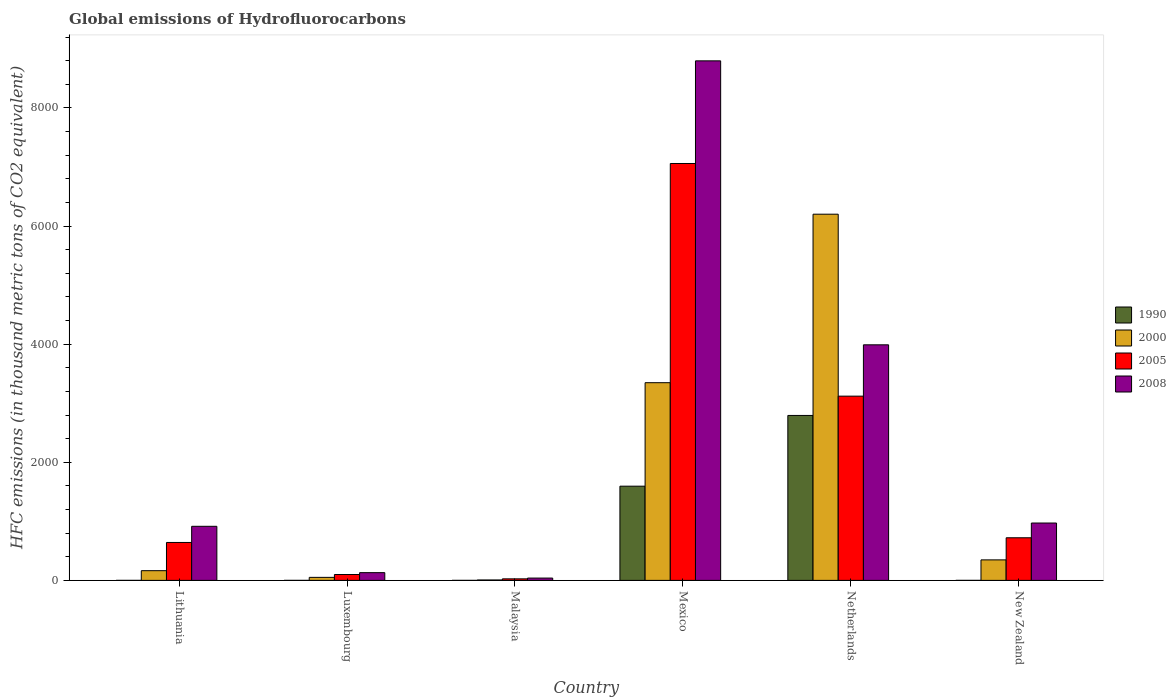How many groups of bars are there?
Provide a short and direct response. 6. How many bars are there on the 3rd tick from the left?
Your answer should be very brief. 4. In how many cases, is the number of bars for a given country not equal to the number of legend labels?
Your answer should be very brief. 0. What is the global emissions of Hydrofluorocarbons in 1990 in Malaysia?
Provide a succinct answer. 0.1. Across all countries, what is the maximum global emissions of Hydrofluorocarbons in 1990?
Provide a short and direct response. 2792.9. Across all countries, what is the minimum global emissions of Hydrofluorocarbons in 2005?
Your response must be concise. 26.1. In which country was the global emissions of Hydrofluorocarbons in 2005 maximum?
Keep it short and to the point. Mexico. In which country was the global emissions of Hydrofluorocarbons in 2000 minimum?
Your answer should be compact. Malaysia. What is the total global emissions of Hydrofluorocarbons in 1990 in the graph?
Ensure brevity in your answer.  4388.7. What is the difference between the global emissions of Hydrofluorocarbons in 2005 in Luxembourg and that in Netherlands?
Offer a terse response. -3020. What is the difference between the global emissions of Hydrofluorocarbons in 2008 in New Zealand and the global emissions of Hydrofluorocarbons in 2005 in Lithuania?
Give a very brief answer. 329.3. What is the average global emissions of Hydrofluorocarbons in 2008 per country?
Make the answer very short. 2473.87. What is the difference between the global emissions of Hydrofluorocarbons of/in 1990 and global emissions of Hydrofluorocarbons of/in 2008 in Mexico?
Your response must be concise. -7201.6. In how many countries, is the global emissions of Hydrofluorocarbons in 2005 greater than 8400 thousand metric tons?
Give a very brief answer. 0. What is the ratio of the global emissions of Hydrofluorocarbons in 1990 in Lithuania to that in Mexico?
Offer a very short reply. 6.268413464552123e-5. What is the difference between the highest and the second highest global emissions of Hydrofluorocarbons in 1990?
Make the answer very short. 1197.6. What is the difference between the highest and the lowest global emissions of Hydrofluorocarbons in 2000?
Your answer should be very brief. 6193.5. In how many countries, is the global emissions of Hydrofluorocarbons in 2005 greater than the average global emissions of Hydrofluorocarbons in 2005 taken over all countries?
Offer a terse response. 2. Is it the case that in every country, the sum of the global emissions of Hydrofluorocarbons in 2008 and global emissions of Hydrofluorocarbons in 2005 is greater than the sum of global emissions of Hydrofluorocarbons in 2000 and global emissions of Hydrofluorocarbons in 1990?
Offer a terse response. No. What does the 3rd bar from the right in Malaysia represents?
Provide a succinct answer. 2000. Is it the case that in every country, the sum of the global emissions of Hydrofluorocarbons in 2005 and global emissions of Hydrofluorocarbons in 1990 is greater than the global emissions of Hydrofluorocarbons in 2008?
Provide a succinct answer. No. Are all the bars in the graph horizontal?
Provide a succinct answer. No. How many countries are there in the graph?
Offer a terse response. 6. What is the difference between two consecutive major ticks on the Y-axis?
Ensure brevity in your answer.  2000. Are the values on the major ticks of Y-axis written in scientific E-notation?
Your response must be concise. No. Where does the legend appear in the graph?
Offer a very short reply. Center right. How are the legend labels stacked?
Your answer should be very brief. Vertical. What is the title of the graph?
Give a very brief answer. Global emissions of Hydrofluorocarbons. What is the label or title of the Y-axis?
Your answer should be very brief. HFC emissions (in thousand metric tons of CO2 equivalent). What is the HFC emissions (in thousand metric tons of CO2 equivalent) of 2000 in Lithuania?
Offer a terse response. 164.5. What is the HFC emissions (in thousand metric tons of CO2 equivalent) of 2005 in Lithuania?
Your answer should be very brief. 642.1. What is the HFC emissions (in thousand metric tons of CO2 equivalent) in 2008 in Lithuania?
Your answer should be compact. 915.7. What is the HFC emissions (in thousand metric tons of CO2 equivalent) of 1990 in Luxembourg?
Your response must be concise. 0.1. What is the HFC emissions (in thousand metric tons of CO2 equivalent) in 2000 in Luxembourg?
Your answer should be compact. 51.1. What is the HFC emissions (in thousand metric tons of CO2 equivalent) in 2005 in Luxembourg?
Make the answer very short. 99.5. What is the HFC emissions (in thousand metric tons of CO2 equivalent) of 2008 in Luxembourg?
Keep it short and to the point. 131.2. What is the HFC emissions (in thousand metric tons of CO2 equivalent) of 2005 in Malaysia?
Your answer should be compact. 26.1. What is the HFC emissions (in thousand metric tons of CO2 equivalent) of 2008 in Malaysia?
Offer a terse response. 39.2. What is the HFC emissions (in thousand metric tons of CO2 equivalent) in 1990 in Mexico?
Your answer should be very brief. 1595.3. What is the HFC emissions (in thousand metric tons of CO2 equivalent) in 2000 in Mexico?
Ensure brevity in your answer.  3347.3. What is the HFC emissions (in thousand metric tons of CO2 equivalent) of 2005 in Mexico?
Offer a terse response. 7058.9. What is the HFC emissions (in thousand metric tons of CO2 equivalent) of 2008 in Mexico?
Provide a succinct answer. 8796.9. What is the HFC emissions (in thousand metric tons of CO2 equivalent) of 1990 in Netherlands?
Give a very brief answer. 2792.9. What is the HFC emissions (in thousand metric tons of CO2 equivalent) of 2000 in Netherlands?
Offer a terse response. 6200.4. What is the HFC emissions (in thousand metric tons of CO2 equivalent) of 2005 in Netherlands?
Provide a succinct answer. 3119.5. What is the HFC emissions (in thousand metric tons of CO2 equivalent) in 2008 in Netherlands?
Make the answer very short. 3988.8. What is the HFC emissions (in thousand metric tons of CO2 equivalent) of 2000 in New Zealand?
Provide a succinct answer. 347.3. What is the HFC emissions (in thousand metric tons of CO2 equivalent) of 2005 in New Zealand?
Offer a very short reply. 721.7. What is the HFC emissions (in thousand metric tons of CO2 equivalent) in 2008 in New Zealand?
Your answer should be compact. 971.4. Across all countries, what is the maximum HFC emissions (in thousand metric tons of CO2 equivalent) in 1990?
Ensure brevity in your answer.  2792.9. Across all countries, what is the maximum HFC emissions (in thousand metric tons of CO2 equivalent) of 2000?
Your answer should be compact. 6200.4. Across all countries, what is the maximum HFC emissions (in thousand metric tons of CO2 equivalent) in 2005?
Your answer should be compact. 7058.9. Across all countries, what is the maximum HFC emissions (in thousand metric tons of CO2 equivalent) of 2008?
Make the answer very short. 8796.9. Across all countries, what is the minimum HFC emissions (in thousand metric tons of CO2 equivalent) of 1990?
Ensure brevity in your answer.  0.1. Across all countries, what is the minimum HFC emissions (in thousand metric tons of CO2 equivalent) of 2005?
Keep it short and to the point. 26.1. Across all countries, what is the minimum HFC emissions (in thousand metric tons of CO2 equivalent) of 2008?
Your response must be concise. 39.2. What is the total HFC emissions (in thousand metric tons of CO2 equivalent) in 1990 in the graph?
Your answer should be very brief. 4388.7. What is the total HFC emissions (in thousand metric tons of CO2 equivalent) of 2000 in the graph?
Make the answer very short. 1.01e+04. What is the total HFC emissions (in thousand metric tons of CO2 equivalent) of 2005 in the graph?
Your answer should be very brief. 1.17e+04. What is the total HFC emissions (in thousand metric tons of CO2 equivalent) of 2008 in the graph?
Your answer should be very brief. 1.48e+04. What is the difference between the HFC emissions (in thousand metric tons of CO2 equivalent) in 2000 in Lithuania and that in Luxembourg?
Provide a succinct answer. 113.4. What is the difference between the HFC emissions (in thousand metric tons of CO2 equivalent) in 2005 in Lithuania and that in Luxembourg?
Your answer should be very brief. 542.6. What is the difference between the HFC emissions (in thousand metric tons of CO2 equivalent) of 2008 in Lithuania and that in Luxembourg?
Keep it short and to the point. 784.5. What is the difference between the HFC emissions (in thousand metric tons of CO2 equivalent) of 2000 in Lithuania and that in Malaysia?
Your answer should be very brief. 157.6. What is the difference between the HFC emissions (in thousand metric tons of CO2 equivalent) of 2005 in Lithuania and that in Malaysia?
Offer a terse response. 616. What is the difference between the HFC emissions (in thousand metric tons of CO2 equivalent) in 2008 in Lithuania and that in Malaysia?
Ensure brevity in your answer.  876.5. What is the difference between the HFC emissions (in thousand metric tons of CO2 equivalent) of 1990 in Lithuania and that in Mexico?
Ensure brevity in your answer.  -1595.2. What is the difference between the HFC emissions (in thousand metric tons of CO2 equivalent) of 2000 in Lithuania and that in Mexico?
Your answer should be very brief. -3182.8. What is the difference between the HFC emissions (in thousand metric tons of CO2 equivalent) of 2005 in Lithuania and that in Mexico?
Provide a short and direct response. -6416.8. What is the difference between the HFC emissions (in thousand metric tons of CO2 equivalent) in 2008 in Lithuania and that in Mexico?
Your answer should be compact. -7881.2. What is the difference between the HFC emissions (in thousand metric tons of CO2 equivalent) of 1990 in Lithuania and that in Netherlands?
Give a very brief answer. -2792.8. What is the difference between the HFC emissions (in thousand metric tons of CO2 equivalent) in 2000 in Lithuania and that in Netherlands?
Your answer should be very brief. -6035.9. What is the difference between the HFC emissions (in thousand metric tons of CO2 equivalent) of 2005 in Lithuania and that in Netherlands?
Provide a short and direct response. -2477.4. What is the difference between the HFC emissions (in thousand metric tons of CO2 equivalent) of 2008 in Lithuania and that in Netherlands?
Your answer should be compact. -3073.1. What is the difference between the HFC emissions (in thousand metric tons of CO2 equivalent) in 2000 in Lithuania and that in New Zealand?
Offer a very short reply. -182.8. What is the difference between the HFC emissions (in thousand metric tons of CO2 equivalent) in 2005 in Lithuania and that in New Zealand?
Keep it short and to the point. -79.6. What is the difference between the HFC emissions (in thousand metric tons of CO2 equivalent) in 2008 in Lithuania and that in New Zealand?
Your answer should be very brief. -55.7. What is the difference between the HFC emissions (in thousand metric tons of CO2 equivalent) of 1990 in Luxembourg and that in Malaysia?
Make the answer very short. 0. What is the difference between the HFC emissions (in thousand metric tons of CO2 equivalent) of 2000 in Luxembourg and that in Malaysia?
Offer a terse response. 44.2. What is the difference between the HFC emissions (in thousand metric tons of CO2 equivalent) in 2005 in Luxembourg and that in Malaysia?
Offer a terse response. 73.4. What is the difference between the HFC emissions (in thousand metric tons of CO2 equivalent) in 2008 in Luxembourg and that in Malaysia?
Make the answer very short. 92. What is the difference between the HFC emissions (in thousand metric tons of CO2 equivalent) in 1990 in Luxembourg and that in Mexico?
Your response must be concise. -1595.2. What is the difference between the HFC emissions (in thousand metric tons of CO2 equivalent) of 2000 in Luxembourg and that in Mexico?
Keep it short and to the point. -3296.2. What is the difference between the HFC emissions (in thousand metric tons of CO2 equivalent) of 2005 in Luxembourg and that in Mexico?
Provide a succinct answer. -6959.4. What is the difference between the HFC emissions (in thousand metric tons of CO2 equivalent) of 2008 in Luxembourg and that in Mexico?
Make the answer very short. -8665.7. What is the difference between the HFC emissions (in thousand metric tons of CO2 equivalent) of 1990 in Luxembourg and that in Netherlands?
Make the answer very short. -2792.8. What is the difference between the HFC emissions (in thousand metric tons of CO2 equivalent) of 2000 in Luxembourg and that in Netherlands?
Provide a succinct answer. -6149.3. What is the difference between the HFC emissions (in thousand metric tons of CO2 equivalent) of 2005 in Luxembourg and that in Netherlands?
Keep it short and to the point. -3020. What is the difference between the HFC emissions (in thousand metric tons of CO2 equivalent) of 2008 in Luxembourg and that in Netherlands?
Offer a terse response. -3857.6. What is the difference between the HFC emissions (in thousand metric tons of CO2 equivalent) of 1990 in Luxembourg and that in New Zealand?
Provide a succinct answer. -0.1. What is the difference between the HFC emissions (in thousand metric tons of CO2 equivalent) of 2000 in Luxembourg and that in New Zealand?
Provide a succinct answer. -296.2. What is the difference between the HFC emissions (in thousand metric tons of CO2 equivalent) of 2005 in Luxembourg and that in New Zealand?
Your response must be concise. -622.2. What is the difference between the HFC emissions (in thousand metric tons of CO2 equivalent) in 2008 in Luxembourg and that in New Zealand?
Make the answer very short. -840.2. What is the difference between the HFC emissions (in thousand metric tons of CO2 equivalent) in 1990 in Malaysia and that in Mexico?
Offer a terse response. -1595.2. What is the difference between the HFC emissions (in thousand metric tons of CO2 equivalent) in 2000 in Malaysia and that in Mexico?
Offer a very short reply. -3340.4. What is the difference between the HFC emissions (in thousand metric tons of CO2 equivalent) of 2005 in Malaysia and that in Mexico?
Your answer should be very brief. -7032.8. What is the difference between the HFC emissions (in thousand metric tons of CO2 equivalent) of 2008 in Malaysia and that in Mexico?
Provide a short and direct response. -8757.7. What is the difference between the HFC emissions (in thousand metric tons of CO2 equivalent) in 1990 in Malaysia and that in Netherlands?
Give a very brief answer. -2792.8. What is the difference between the HFC emissions (in thousand metric tons of CO2 equivalent) of 2000 in Malaysia and that in Netherlands?
Provide a succinct answer. -6193.5. What is the difference between the HFC emissions (in thousand metric tons of CO2 equivalent) in 2005 in Malaysia and that in Netherlands?
Provide a succinct answer. -3093.4. What is the difference between the HFC emissions (in thousand metric tons of CO2 equivalent) of 2008 in Malaysia and that in Netherlands?
Provide a succinct answer. -3949.6. What is the difference between the HFC emissions (in thousand metric tons of CO2 equivalent) in 1990 in Malaysia and that in New Zealand?
Give a very brief answer. -0.1. What is the difference between the HFC emissions (in thousand metric tons of CO2 equivalent) in 2000 in Malaysia and that in New Zealand?
Provide a succinct answer. -340.4. What is the difference between the HFC emissions (in thousand metric tons of CO2 equivalent) in 2005 in Malaysia and that in New Zealand?
Give a very brief answer. -695.6. What is the difference between the HFC emissions (in thousand metric tons of CO2 equivalent) of 2008 in Malaysia and that in New Zealand?
Keep it short and to the point. -932.2. What is the difference between the HFC emissions (in thousand metric tons of CO2 equivalent) of 1990 in Mexico and that in Netherlands?
Your answer should be very brief. -1197.6. What is the difference between the HFC emissions (in thousand metric tons of CO2 equivalent) in 2000 in Mexico and that in Netherlands?
Offer a very short reply. -2853.1. What is the difference between the HFC emissions (in thousand metric tons of CO2 equivalent) in 2005 in Mexico and that in Netherlands?
Offer a terse response. 3939.4. What is the difference between the HFC emissions (in thousand metric tons of CO2 equivalent) in 2008 in Mexico and that in Netherlands?
Ensure brevity in your answer.  4808.1. What is the difference between the HFC emissions (in thousand metric tons of CO2 equivalent) of 1990 in Mexico and that in New Zealand?
Offer a very short reply. 1595.1. What is the difference between the HFC emissions (in thousand metric tons of CO2 equivalent) of 2000 in Mexico and that in New Zealand?
Ensure brevity in your answer.  3000. What is the difference between the HFC emissions (in thousand metric tons of CO2 equivalent) of 2005 in Mexico and that in New Zealand?
Give a very brief answer. 6337.2. What is the difference between the HFC emissions (in thousand metric tons of CO2 equivalent) in 2008 in Mexico and that in New Zealand?
Keep it short and to the point. 7825.5. What is the difference between the HFC emissions (in thousand metric tons of CO2 equivalent) of 1990 in Netherlands and that in New Zealand?
Your response must be concise. 2792.7. What is the difference between the HFC emissions (in thousand metric tons of CO2 equivalent) in 2000 in Netherlands and that in New Zealand?
Ensure brevity in your answer.  5853.1. What is the difference between the HFC emissions (in thousand metric tons of CO2 equivalent) in 2005 in Netherlands and that in New Zealand?
Keep it short and to the point. 2397.8. What is the difference between the HFC emissions (in thousand metric tons of CO2 equivalent) of 2008 in Netherlands and that in New Zealand?
Your answer should be very brief. 3017.4. What is the difference between the HFC emissions (in thousand metric tons of CO2 equivalent) in 1990 in Lithuania and the HFC emissions (in thousand metric tons of CO2 equivalent) in 2000 in Luxembourg?
Keep it short and to the point. -51. What is the difference between the HFC emissions (in thousand metric tons of CO2 equivalent) of 1990 in Lithuania and the HFC emissions (in thousand metric tons of CO2 equivalent) of 2005 in Luxembourg?
Give a very brief answer. -99.4. What is the difference between the HFC emissions (in thousand metric tons of CO2 equivalent) in 1990 in Lithuania and the HFC emissions (in thousand metric tons of CO2 equivalent) in 2008 in Luxembourg?
Offer a very short reply. -131.1. What is the difference between the HFC emissions (in thousand metric tons of CO2 equivalent) of 2000 in Lithuania and the HFC emissions (in thousand metric tons of CO2 equivalent) of 2005 in Luxembourg?
Provide a succinct answer. 65. What is the difference between the HFC emissions (in thousand metric tons of CO2 equivalent) in 2000 in Lithuania and the HFC emissions (in thousand metric tons of CO2 equivalent) in 2008 in Luxembourg?
Your answer should be very brief. 33.3. What is the difference between the HFC emissions (in thousand metric tons of CO2 equivalent) in 2005 in Lithuania and the HFC emissions (in thousand metric tons of CO2 equivalent) in 2008 in Luxembourg?
Your response must be concise. 510.9. What is the difference between the HFC emissions (in thousand metric tons of CO2 equivalent) in 1990 in Lithuania and the HFC emissions (in thousand metric tons of CO2 equivalent) in 2000 in Malaysia?
Give a very brief answer. -6.8. What is the difference between the HFC emissions (in thousand metric tons of CO2 equivalent) in 1990 in Lithuania and the HFC emissions (in thousand metric tons of CO2 equivalent) in 2008 in Malaysia?
Make the answer very short. -39.1. What is the difference between the HFC emissions (in thousand metric tons of CO2 equivalent) in 2000 in Lithuania and the HFC emissions (in thousand metric tons of CO2 equivalent) in 2005 in Malaysia?
Your response must be concise. 138.4. What is the difference between the HFC emissions (in thousand metric tons of CO2 equivalent) of 2000 in Lithuania and the HFC emissions (in thousand metric tons of CO2 equivalent) of 2008 in Malaysia?
Ensure brevity in your answer.  125.3. What is the difference between the HFC emissions (in thousand metric tons of CO2 equivalent) in 2005 in Lithuania and the HFC emissions (in thousand metric tons of CO2 equivalent) in 2008 in Malaysia?
Make the answer very short. 602.9. What is the difference between the HFC emissions (in thousand metric tons of CO2 equivalent) in 1990 in Lithuania and the HFC emissions (in thousand metric tons of CO2 equivalent) in 2000 in Mexico?
Provide a short and direct response. -3347.2. What is the difference between the HFC emissions (in thousand metric tons of CO2 equivalent) of 1990 in Lithuania and the HFC emissions (in thousand metric tons of CO2 equivalent) of 2005 in Mexico?
Provide a succinct answer. -7058.8. What is the difference between the HFC emissions (in thousand metric tons of CO2 equivalent) in 1990 in Lithuania and the HFC emissions (in thousand metric tons of CO2 equivalent) in 2008 in Mexico?
Provide a short and direct response. -8796.8. What is the difference between the HFC emissions (in thousand metric tons of CO2 equivalent) in 2000 in Lithuania and the HFC emissions (in thousand metric tons of CO2 equivalent) in 2005 in Mexico?
Offer a very short reply. -6894.4. What is the difference between the HFC emissions (in thousand metric tons of CO2 equivalent) in 2000 in Lithuania and the HFC emissions (in thousand metric tons of CO2 equivalent) in 2008 in Mexico?
Your response must be concise. -8632.4. What is the difference between the HFC emissions (in thousand metric tons of CO2 equivalent) in 2005 in Lithuania and the HFC emissions (in thousand metric tons of CO2 equivalent) in 2008 in Mexico?
Offer a terse response. -8154.8. What is the difference between the HFC emissions (in thousand metric tons of CO2 equivalent) in 1990 in Lithuania and the HFC emissions (in thousand metric tons of CO2 equivalent) in 2000 in Netherlands?
Your response must be concise. -6200.3. What is the difference between the HFC emissions (in thousand metric tons of CO2 equivalent) of 1990 in Lithuania and the HFC emissions (in thousand metric tons of CO2 equivalent) of 2005 in Netherlands?
Your answer should be compact. -3119.4. What is the difference between the HFC emissions (in thousand metric tons of CO2 equivalent) of 1990 in Lithuania and the HFC emissions (in thousand metric tons of CO2 equivalent) of 2008 in Netherlands?
Make the answer very short. -3988.7. What is the difference between the HFC emissions (in thousand metric tons of CO2 equivalent) of 2000 in Lithuania and the HFC emissions (in thousand metric tons of CO2 equivalent) of 2005 in Netherlands?
Offer a terse response. -2955. What is the difference between the HFC emissions (in thousand metric tons of CO2 equivalent) of 2000 in Lithuania and the HFC emissions (in thousand metric tons of CO2 equivalent) of 2008 in Netherlands?
Provide a short and direct response. -3824.3. What is the difference between the HFC emissions (in thousand metric tons of CO2 equivalent) of 2005 in Lithuania and the HFC emissions (in thousand metric tons of CO2 equivalent) of 2008 in Netherlands?
Ensure brevity in your answer.  -3346.7. What is the difference between the HFC emissions (in thousand metric tons of CO2 equivalent) of 1990 in Lithuania and the HFC emissions (in thousand metric tons of CO2 equivalent) of 2000 in New Zealand?
Your answer should be compact. -347.2. What is the difference between the HFC emissions (in thousand metric tons of CO2 equivalent) in 1990 in Lithuania and the HFC emissions (in thousand metric tons of CO2 equivalent) in 2005 in New Zealand?
Give a very brief answer. -721.6. What is the difference between the HFC emissions (in thousand metric tons of CO2 equivalent) of 1990 in Lithuania and the HFC emissions (in thousand metric tons of CO2 equivalent) of 2008 in New Zealand?
Give a very brief answer. -971.3. What is the difference between the HFC emissions (in thousand metric tons of CO2 equivalent) of 2000 in Lithuania and the HFC emissions (in thousand metric tons of CO2 equivalent) of 2005 in New Zealand?
Your response must be concise. -557.2. What is the difference between the HFC emissions (in thousand metric tons of CO2 equivalent) of 2000 in Lithuania and the HFC emissions (in thousand metric tons of CO2 equivalent) of 2008 in New Zealand?
Provide a short and direct response. -806.9. What is the difference between the HFC emissions (in thousand metric tons of CO2 equivalent) in 2005 in Lithuania and the HFC emissions (in thousand metric tons of CO2 equivalent) in 2008 in New Zealand?
Your answer should be compact. -329.3. What is the difference between the HFC emissions (in thousand metric tons of CO2 equivalent) of 1990 in Luxembourg and the HFC emissions (in thousand metric tons of CO2 equivalent) of 2000 in Malaysia?
Offer a terse response. -6.8. What is the difference between the HFC emissions (in thousand metric tons of CO2 equivalent) of 1990 in Luxembourg and the HFC emissions (in thousand metric tons of CO2 equivalent) of 2008 in Malaysia?
Your answer should be compact. -39.1. What is the difference between the HFC emissions (in thousand metric tons of CO2 equivalent) in 2005 in Luxembourg and the HFC emissions (in thousand metric tons of CO2 equivalent) in 2008 in Malaysia?
Your response must be concise. 60.3. What is the difference between the HFC emissions (in thousand metric tons of CO2 equivalent) of 1990 in Luxembourg and the HFC emissions (in thousand metric tons of CO2 equivalent) of 2000 in Mexico?
Your response must be concise. -3347.2. What is the difference between the HFC emissions (in thousand metric tons of CO2 equivalent) in 1990 in Luxembourg and the HFC emissions (in thousand metric tons of CO2 equivalent) in 2005 in Mexico?
Offer a very short reply. -7058.8. What is the difference between the HFC emissions (in thousand metric tons of CO2 equivalent) in 1990 in Luxembourg and the HFC emissions (in thousand metric tons of CO2 equivalent) in 2008 in Mexico?
Your answer should be compact. -8796.8. What is the difference between the HFC emissions (in thousand metric tons of CO2 equivalent) in 2000 in Luxembourg and the HFC emissions (in thousand metric tons of CO2 equivalent) in 2005 in Mexico?
Your answer should be very brief. -7007.8. What is the difference between the HFC emissions (in thousand metric tons of CO2 equivalent) in 2000 in Luxembourg and the HFC emissions (in thousand metric tons of CO2 equivalent) in 2008 in Mexico?
Provide a short and direct response. -8745.8. What is the difference between the HFC emissions (in thousand metric tons of CO2 equivalent) in 2005 in Luxembourg and the HFC emissions (in thousand metric tons of CO2 equivalent) in 2008 in Mexico?
Provide a short and direct response. -8697.4. What is the difference between the HFC emissions (in thousand metric tons of CO2 equivalent) of 1990 in Luxembourg and the HFC emissions (in thousand metric tons of CO2 equivalent) of 2000 in Netherlands?
Offer a terse response. -6200.3. What is the difference between the HFC emissions (in thousand metric tons of CO2 equivalent) in 1990 in Luxembourg and the HFC emissions (in thousand metric tons of CO2 equivalent) in 2005 in Netherlands?
Provide a succinct answer. -3119.4. What is the difference between the HFC emissions (in thousand metric tons of CO2 equivalent) of 1990 in Luxembourg and the HFC emissions (in thousand metric tons of CO2 equivalent) of 2008 in Netherlands?
Offer a terse response. -3988.7. What is the difference between the HFC emissions (in thousand metric tons of CO2 equivalent) of 2000 in Luxembourg and the HFC emissions (in thousand metric tons of CO2 equivalent) of 2005 in Netherlands?
Offer a very short reply. -3068.4. What is the difference between the HFC emissions (in thousand metric tons of CO2 equivalent) in 2000 in Luxembourg and the HFC emissions (in thousand metric tons of CO2 equivalent) in 2008 in Netherlands?
Ensure brevity in your answer.  -3937.7. What is the difference between the HFC emissions (in thousand metric tons of CO2 equivalent) in 2005 in Luxembourg and the HFC emissions (in thousand metric tons of CO2 equivalent) in 2008 in Netherlands?
Provide a short and direct response. -3889.3. What is the difference between the HFC emissions (in thousand metric tons of CO2 equivalent) in 1990 in Luxembourg and the HFC emissions (in thousand metric tons of CO2 equivalent) in 2000 in New Zealand?
Your answer should be compact. -347.2. What is the difference between the HFC emissions (in thousand metric tons of CO2 equivalent) of 1990 in Luxembourg and the HFC emissions (in thousand metric tons of CO2 equivalent) of 2005 in New Zealand?
Provide a succinct answer. -721.6. What is the difference between the HFC emissions (in thousand metric tons of CO2 equivalent) of 1990 in Luxembourg and the HFC emissions (in thousand metric tons of CO2 equivalent) of 2008 in New Zealand?
Ensure brevity in your answer.  -971.3. What is the difference between the HFC emissions (in thousand metric tons of CO2 equivalent) of 2000 in Luxembourg and the HFC emissions (in thousand metric tons of CO2 equivalent) of 2005 in New Zealand?
Offer a terse response. -670.6. What is the difference between the HFC emissions (in thousand metric tons of CO2 equivalent) in 2000 in Luxembourg and the HFC emissions (in thousand metric tons of CO2 equivalent) in 2008 in New Zealand?
Your answer should be compact. -920.3. What is the difference between the HFC emissions (in thousand metric tons of CO2 equivalent) in 2005 in Luxembourg and the HFC emissions (in thousand metric tons of CO2 equivalent) in 2008 in New Zealand?
Give a very brief answer. -871.9. What is the difference between the HFC emissions (in thousand metric tons of CO2 equivalent) in 1990 in Malaysia and the HFC emissions (in thousand metric tons of CO2 equivalent) in 2000 in Mexico?
Your answer should be very brief. -3347.2. What is the difference between the HFC emissions (in thousand metric tons of CO2 equivalent) in 1990 in Malaysia and the HFC emissions (in thousand metric tons of CO2 equivalent) in 2005 in Mexico?
Offer a terse response. -7058.8. What is the difference between the HFC emissions (in thousand metric tons of CO2 equivalent) in 1990 in Malaysia and the HFC emissions (in thousand metric tons of CO2 equivalent) in 2008 in Mexico?
Offer a very short reply. -8796.8. What is the difference between the HFC emissions (in thousand metric tons of CO2 equivalent) of 2000 in Malaysia and the HFC emissions (in thousand metric tons of CO2 equivalent) of 2005 in Mexico?
Offer a terse response. -7052. What is the difference between the HFC emissions (in thousand metric tons of CO2 equivalent) of 2000 in Malaysia and the HFC emissions (in thousand metric tons of CO2 equivalent) of 2008 in Mexico?
Your answer should be compact. -8790. What is the difference between the HFC emissions (in thousand metric tons of CO2 equivalent) of 2005 in Malaysia and the HFC emissions (in thousand metric tons of CO2 equivalent) of 2008 in Mexico?
Provide a succinct answer. -8770.8. What is the difference between the HFC emissions (in thousand metric tons of CO2 equivalent) in 1990 in Malaysia and the HFC emissions (in thousand metric tons of CO2 equivalent) in 2000 in Netherlands?
Provide a succinct answer. -6200.3. What is the difference between the HFC emissions (in thousand metric tons of CO2 equivalent) in 1990 in Malaysia and the HFC emissions (in thousand metric tons of CO2 equivalent) in 2005 in Netherlands?
Your answer should be compact. -3119.4. What is the difference between the HFC emissions (in thousand metric tons of CO2 equivalent) in 1990 in Malaysia and the HFC emissions (in thousand metric tons of CO2 equivalent) in 2008 in Netherlands?
Your answer should be very brief. -3988.7. What is the difference between the HFC emissions (in thousand metric tons of CO2 equivalent) in 2000 in Malaysia and the HFC emissions (in thousand metric tons of CO2 equivalent) in 2005 in Netherlands?
Offer a very short reply. -3112.6. What is the difference between the HFC emissions (in thousand metric tons of CO2 equivalent) in 2000 in Malaysia and the HFC emissions (in thousand metric tons of CO2 equivalent) in 2008 in Netherlands?
Your response must be concise. -3981.9. What is the difference between the HFC emissions (in thousand metric tons of CO2 equivalent) of 2005 in Malaysia and the HFC emissions (in thousand metric tons of CO2 equivalent) of 2008 in Netherlands?
Give a very brief answer. -3962.7. What is the difference between the HFC emissions (in thousand metric tons of CO2 equivalent) in 1990 in Malaysia and the HFC emissions (in thousand metric tons of CO2 equivalent) in 2000 in New Zealand?
Give a very brief answer. -347.2. What is the difference between the HFC emissions (in thousand metric tons of CO2 equivalent) of 1990 in Malaysia and the HFC emissions (in thousand metric tons of CO2 equivalent) of 2005 in New Zealand?
Make the answer very short. -721.6. What is the difference between the HFC emissions (in thousand metric tons of CO2 equivalent) of 1990 in Malaysia and the HFC emissions (in thousand metric tons of CO2 equivalent) of 2008 in New Zealand?
Your answer should be very brief. -971.3. What is the difference between the HFC emissions (in thousand metric tons of CO2 equivalent) of 2000 in Malaysia and the HFC emissions (in thousand metric tons of CO2 equivalent) of 2005 in New Zealand?
Your response must be concise. -714.8. What is the difference between the HFC emissions (in thousand metric tons of CO2 equivalent) in 2000 in Malaysia and the HFC emissions (in thousand metric tons of CO2 equivalent) in 2008 in New Zealand?
Ensure brevity in your answer.  -964.5. What is the difference between the HFC emissions (in thousand metric tons of CO2 equivalent) of 2005 in Malaysia and the HFC emissions (in thousand metric tons of CO2 equivalent) of 2008 in New Zealand?
Make the answer very short. -945.3. What is the difference between the HFC emissions (in thousand metric tons of CO2 equivalent) in 1990 in Mexico and the HFC emissions (in thousand metric tons of CO2 equivalent) in 2000 in Netherlands?
Offer a very short reply. -4605.1. What is the difference between the HFC emissions (in thousand metric tons of CO2 equivalent) in 1990 in Mexico and the HFC emissions (in thousand metric tons of CO2 equivalent) in 2005 in Netherlands?
Your answer should be very brief. -1524.2. What is the difference between the HFC emissions (in thousand metric tons of CO2 equivalent) of 1990 in Mexico and the HFC emissions (in thousand metric tons of CO2 equivalent) of 2008 in Netherlands?
Offer a very short reply. -2393.5. What is the difference between the HFC emissions (in thousand metric tons of CO2 equivalent) of 2000 in Mexico and the HFC emissions (in thousand metric tons of CO2 equivalent) of 2005 in Netherlands?
Your response must be concise. 227.8. What is the difference between the HFC emissions (in thousand metric tons of CO2 equivalent) in 2000 in Mexico and the HFC emissions (in thousand metric tons of CO2 equivalent) in 2008 in Netherlands?
Offer a very short reply. -641.5. What is the difference between the HFC emissions (in thousand metric tons of CO2 equivalent) in 2005 in Mexico and the HFC emissions (in thousand metric tons of CO2 equivalent) in 2008 in Netherlands?
Offer a terse response. 3070.1. What is the difference between the HFC emissions (in thousand metric tons of CO2 equivalent) in 1990 in Mexico and the HFC emissions (in thousand metric tons of CO2 equivalent) in 2000 in New Zealand?
Your answer should be very brief. 1248. What is the difference between the HFC emissions (in thousand metric tons of CO2 equivalent) of 1990 in Mexico and the HFC emissions (in thousand metric tons of CO2 equivalent) of 2005 in New Zealand?
Provide a succinct answer. 873.6. What is the difference between the HFC emissions (in thousand metric tons of CO2 equivalent) of 1990 in Mexico and the HFC emissions (in thousand metric tons of CO2 equivalent) of 2008 in New Zealand?
Provide a succinct answer. 623.9. What is the difference between the HFC emissions (in thousand metric tons of CO2 equivalent) of 2000 in Mexico and the HFC emissions (in thousand metric tons of CO2 equivalent) of 2005 in New Zealand?
Offer a terse response. 2625.6. What is the difference between the HFC emissions (in thousand metric tons of CO2 equivalent) of 2000 in Mexico and the HFC emissions (in thousand metric tons of CO2 equivalent) of 2008 in New Zealand?
Your response must be concise. 2375.9. What is the difference between the HFC emissions (in thousand metric tons of CO2 equivalent) in 2005 in Mexico and the HFC emissions (in thousand metric tons of CO2 equivalent) in 2008 in New Zealand?
Offer a very short reply. 6087.5. What is the difference between the HFC emissions (in thousand metric tons of CO2 equivalent) of 1990 in Netherlands and the HFC emissions (in thousand metric tons of CO2 equivalent) of 2000 in New Zealand?
Give a very brief answer. 2445.6. What is the difference between the HFC emissions (in thousand metric tons of CO2 equivalent) in 1990 in Netherlands and the HFC emissions (in thousand metric tons of CO2 equivalent) in 2005 in New Zealand?
Your answer should be very brief. 2071.2. What is the difference between the HFC emissions (in thousand metric tons of CO2 equivalent) of 1990 in Netherlands and the HFC emissions (in thousand metric tons of CO2 equivalent) of 2008 in New Zealand?
Offer a very short reply. 1821.5. What is the difference between the HFC emissions (in thousand metric tons of CO2 equivalent) in 2000 in Netherlands and the HFC emissions (in thousand metric tons of CO2 equivalent) in 2005 in New Zealand?
Your answer should be compact. 5478.7. What is the difference between the HFC emissions (in thousand metric tons of CO2 equivalent) in 2000 in Netherlands and the HFC emissions (in thousand metric tons of CO2 equivalent) in 2008 in New Zealand?
Ensure brevity in your answer.  5229. What is the difference between the HFC emissions (in thousand metric tons of CO2 equivalent) of 2005 in Netherlands and the HFC emissions (in thousand metric tons of CO2 equivalent) of 2008 in New Zealand?
Provide a short and direct response. 2148.1. What is the average HFC emissions (in thousand metric tons of CO2 equivalent) of 1990 per country?
Your answer should be very brief. 731.45. What is the average HFC emissions (in thousand metric tons of CO2 equivalent) of 2000 per country?
Provide a succinct answer. 1686.25. What is the average HFC emissions (in thousand metric tons of CO2 equivalent) of 2005 per country?
Provide a succinct answer. 1944.63. What is the average HFC emissions (in thousand metric tons of CO2 equivalent) in 2008 per country?
Your answer should be very brief. 2473.87. What is the difference between the HFC emissions (in thousand metric tons of CO2 equivalent) in 1990 and HFC emissions (in thousand metric tons of CO2 equivalent) in 2000 in Lithuania?
Give a very brief answer. -164.4. What is the difference between the HFC emissions (in thousand metric tons of CO2 equivalent) of 1990 and HFC emissions (in thousand metric tons of CO2 equivalent) of 2005 in Lithuania?
Your answer should be very brief. -642. What is the difference between the HFC emissions (in thousand metric tons of CO2 equivalent) of 1990 and HFC emissions (in thousand metric tons of CO2 equivalent) of 2008 in Lithuania?
Give a very brief answer. -915.6. What is the difference between the HFC emissions (in thousand metric tons of CO2 equivalent) in 2000 and HFC emissions (in thousand metric tons of CO2 equivalent) in 2005 in Lithuania?
Give a very brief answer. -477.6. What is the difference between the HFC emissions (in thousand metric tons of CO2 equivalent) in 2000 and HFC emissions (in thousand metric tons of CO2 equivalent) in 2008 in Lithuania?
Provide a short and direct response. -751.2. What is the difference between the HFC emissions (in thousand metric tons of CO2 equivalent) in 2005 and HFC emissions (in thousand metric tons of CO2 equivalent) in 2008 in Lithuania?
Give a very brief answer. -273.6. What is the difference between the HFC emissions (in thousand metric tons of CO2 equivalent) of 1990 and HFC emissions (in thousand metric tons of CO2 equivalent) of 2000 in Luxembourg?
Your response must be concise. -51. What is the difference between the HFC emissions (in thousand metric tons of CO2 equivalent) in 1990 and HFC emissions (in thousand metric tons of CO2 equivalent) in 2005 in Luxembourg?
Ensure brevity in your answer.  -99.4. What is the difference between the HFC emissions (in thousand metric tons of CO2 equivalent) in 1990 and HFC emissions (in thousand metric tons of CO2 equivalent) in 2008 in Luxembourg?
Your answer should be very brief. -131.1. What is the difference between the HFC emissions (in thousand metric tons of CO2 equivalent) of 2000 and HFC emissions (in thousand metric tons of CO2 equivalent) of 2005 in Luxembourg?
Keep it short and to the point. -48.4. What is the difference between the HFC emissions (in thousand metric tons of CO2 equivalent) in 2000 and HFC emissions (in thousand metric tons of CO2 equivalent) in 2008 in Luxembourg?
Ensure brevity in your answer.  -80.1. What is the difference between the HFC emissions (in thousand metric tons of CO2 equivalent) of 2005 and HFC emissions (in thousand metric tons of CO2 equivalent) of 2008 in Luxembourg?
Your response must be concise. -31.7. What is the difference between the HFC emissions (in thousand metric tons of CO2 equivalent) of 1990 and HFC emissions (in thousand metric tons of CO2 equivalent) of 2008 in Malaysia?
Your answer should be compact. -39.1. What is the difference between the HFC emissions (in thousand metric tons of CO2 equivalent) of 2000 and HFC emissions (in thousand metric tons of CO2 equivalent) of 2005 in Malaysia?
Your answer should be very brief. -19.2. What is the difference between the HFC emissions (in thousand metric tons of CO2 equivalent) in 2000 and HFC emissions (in thousand metric tons of CO2 equivalent) in 2008 in Malaysia?
Keep it short and to the point. -32.3. What is the difference between the HFC emissions (in thousand metric tons of CO2 equivalent) of 2005 and HFC emissions (in thousand metric tons of CO2 equivalent) of 2008 in Malaysia?
Your response must be concise. -13.1. What is the difference between the HFC emissions (in thousand metric tons of CO2 equivalent) in 1990 and HFC emissions (in thousand metric tons of CO2 equivalent) in 2000 in Mexico?
Give a very brief answer. -1752. What is the difference between the HFC emissions (in thousand metric tons of CO2 equivalent) in 1990 and HFC emissions (in thousand metric tons of CO2 equivalent) in 2005 in Mexico?
Make the answer very short. -5463.6. What is the difference between the HFC emissions (in thousand metric tons of CO2 equivalent) in 1990 and HFC emissions (in thousand metric tons of CO2 equivalent) in 2008 in Mexico?
Your answer should be compact. -7201.6. What is the difference between the HFC emissions (in thousand metric tons of CO2 equivalent) of 2000 and HFC emissions (in thousand metric tons of CO2 equivalent) of 2005 in Mexico?
Your answer should be very brief. -3711.6. What is the difference between the HFC emissions (in thousand metric tons of CO2 equivalent) of 2000 and HFC emissions (in thousand metric tons of CO2 equivalent) of 2008 in Mexico?
Your answer should be compact. -5449.6. What is the difference between the HFC emissions (in thousand metric tons of CO2 equivalent) of 2005 and HFC emissions (in thousand metric tons of CO2 equivalent) of 2008 in Mexico?
Ensure brevity in your answer.  -1738. What is the difference between the HFC emissions (in thousand metric tons of CO2 equivalent) in 1990 and HFC emissions (in thousand metric tons of CO2 equivalent) in 2000 in Netherlands?
Your response must be concise. -3407.5. What is the difference between the HFC emissions (in thousand metric tons of CO2 equivalent) in 1990 and HFC emissions (in thousand metric tons of CO2 equivalent) in 2005 in Netherlands?
Provide a succinct answer. -326.6. What is the difference between the HFC emissions (in thousand metric tons of CO2 equivalent) in 1990 and HFC emissions (in thousand metric tons of CO2 equivalent) in 2008 in Netherlands?
Give a very brief answer. -1195.9. What is the difference between the HFC emissions (in thousand metric tons of CO2 equivalent) in 2000 and HFC emissions (in thousand metric tons of CO2 equivalent) in 2005 in Netherlands?
Your answer should be very brief. 3080.9. What is the difference between the HFC emissions (in thousand metric tons of CO2 equivalent) in 2000 and HFC emissions (in thousand metric tons of CO2 equivalent) in 2008 in Netherlands?
Your answer should be very brief. 2211.6. What is the difference between the HFC emissions (in thousand metric tons of CO2 equivalent) in 2005 and HFC emissions (in thousand metric tons of CO2 equivalent) in 2008 in Netherlands?
Make the answer very short. -869.3. What is the difference between the HFC emissions (in thousand metric tons of CO2 equivalent) of 1990 and HFC emissions (in thousand metric tons of CO2 equivalent) of 2000 in New Zealand?
Offer a very short reply. -347.1. What is the difference between the HFC emissions (in thousand metric tons of CO2 equivalent) in 1990 and HFC emissions (in thousand metric tons of CO2 equivalent) in 2005 in New Zealand?
Give a very brief answer. -721.5. What is the difference between the HFC emissions (in thousand metric tons of CO2 equivalent) of 1990 and HFC emissions (in thousand metric tons of CO2 equivalent) of 2008 in New Zealand?
Provide a succinct answer. -971.2. What is the difference between the HFC emissions (in thousand metric tons of CO2 equivalent) of 2000 and HFC emissions (in thousand metric tons of CO2 equivalent) of 2005 in New Zealand?
Give a very brief answer. -374.4. What is the difference between the HFC emissions (in thousand metric tons of CO2 equivalent) of 2000 and HFC emissions (in thousand metric tons of CO2 equivalent) of 2008 in New Zealand?
Ensure brevity in your answer.  -624.1. What is the difference between the HFC emissions (in thousand metric tons of CO2 equivalent) of 2005 and HFC emissions (in thousand metric tons of CO2 equivalent) of 2008 in New Zealand?
Keep it short and to the point. -249.7. What is the ratio of the HFC emissions (in thousand metric tons of CO2 equivalent) in 2000 in Lithuania to that in Luxembourg?
Ensure brevity in your answer.  3.22. What is the ratio of the HFC emissions (in thousand metric tons of CO2 equivalent) in 2005 in Lithuania to that in Luxembourg?
Give a very brief answer. 6.45. What is the ratio of the HFC emissions (in thousand metric tons of CO2 equivalent) of 2008 in Lithuania to that in Luxembourg?
Make the answer very short. 6.98. What is the ratio of the HFC emissions (in thousand metric tons of CO2 equivalent) in 2000 in Lithuania to that in Malaysia?
Your answer should be compact. 23.84. What is the ratio of the HFC emissions (in thousand metric tons of CO2 equivalent) in 2005 in Lithuania to that in Malaysia?
Your answer should be very brief. 24.6. What is the ratio of the HFC emissions (in thousand metric tons of CO2 equivalent) in 2008 in Lithuania to that in Malaysia?
Provide a succinct answer. 23.36. What is the ratio of the HFC emissions (in thousand metric tons of CO2 equivalent) of 1990 in Lithuania to that in Mexico?
Offer a terse response. 0. What is the ratio of the HFC emissions (in thousand metric tons of CO2 equivalent) of 2000 in Lithuania to that in Mexico?
Offer a terse response. 0.05. What is the ratio of the HFC emissions (in thousand metric tons of CO2 equivalent) in 2005 in Lithuania to that in Mexico?
Your response must be concise. 0.09. What is the ratio of the HFC emissions (in thousand metric tons of CO2 equivalent) of 2008 in Lithuania to that in Mexico?
Your answer should be very brief. 0.1. What is the ratio of the HFC emissions (in thousand metric tons of CO2 equivalent) of 1990 in Lithuania to that in Netherlands?
Ensure brevity in your answer.  0. What is the ratio of the HFC emissions (in thousand metric tons of CO2 equivalent) of 2000 in Lithuania to that in Netherlands?
Your answer should be very brief. 0.03. What is the ratio of the HFC emissions (in thousand metric tons of CO2 equivalent) of 2005 in Lithuania to that in Netherlands?
Your answer should be compact. 0.21. What is the ratio of the HFC emissions (in thousand metric tons of CO2 equivalent) of 2008 in Lithuania to that in Netherlands?
Your response must be concise. 0.23. What is the ratio of the HFC emissions (in thousand metric tons of CO2 equivalent) of 1990 in Lithuania to that in New Zealand?
Give a very brief answer. 0.5. What is the ratio of the HFC emissions (in thousand metric tons of CO2 equivalent) of 2000 in Lithuania to that in New Zealand?
Offer a terse response. 0.47. What is the ratio of the HFC emissions (in thousand metric tons of CO2 equivalent) of 2005 in Lithuania to that in New Zealand?
Your answer should be compact. 0.89. What is the ratio of the HFC emissions (in thousand metric tons of CO2 equivalent) of 2008 in Lithuania to that in New Zealand?
Give a very brief answer. 0.94. What is the ratio of the HFC emissions (in thousand metric tons of CO2 equivalent) of 1990 in Luxembourg to that in Malaysia?
Provide a succinct answer. 1. What is the ratio of the HFC emissions (in thousand metric tons of CO2 equivalent) in 2000 in Luxembourg to that in Malaysia?
Your answer should be very brief. 7.41. What is the ratio of the HFC emissions (in thousand metric tons of CO2 equivalent) of 2005 in Luxembourg to that in Malaysia?
Keep it short and to the point. 3.81. What is the ratio of the HFC emissions (in thousand metric tons of CO2 equivalent) in 2008 in Luxembourg to that in Malaysia?
Keep it short and to the point. 3.35. What is the ratio of the HFC emissions (in thousand metric tons of CO2 equivalent) of 2000 in Luxembourg to that in Mexico?
Ensure brevity in your answer.  0.02. What is the ratio of the HFC emissions (in thousand metric tons of CO2 equivalent) in 2005 in Luxembourg to that in Mexico?
Provide a short and direct response. 0.01. What is the ratio of the HFC emissions (in thousand metric tons of CO2 equivalent) in 2008 in Luxembourg to that in Mexico?
Your answer should be very brief. 0.01. What is the ratio of the HFC emissions (in thousand metric tons of CO2 equivalent) in 1990 in Luxembourg to that in Netherlands?
Your answer should be compact. 0. What is the ratio of the HFC emissions (in thousand metric tons of CO2 equivalent) of 2000 in Luxembourg to that in Netherlands?
Your answer should be compact. 0.01. What is the ratio of the HFC emissions (in thousand metric tons of CO2 equivalent) of 2005 in Luxembourg to that in Netherlands?
Offer a very short reply. 0.03. What is the ratio of the HFC emissions (in thousand metric tons of CO2 equivalent) in 2008 in Luxembourg to that in Netherlands?
Your response must be concise. 0.03. What is the ratio of the HFC emissions (in thousand metric tons of CO2 equivalent) in 2000 in Luxembourg to that in New Zealand?
Make the answer very short. 0.15. What is the ratio of the HFC emissions (in thousand metric tons of CO2 equivalent) in 2005 in Luxembourg to that in New Zealand?
Your answer should be compact. 0.14. What is the ratio of the HFC emissions (in thousand metric tons of CO2 equivalent) in 2008 in Luxembourg to that in New Zealand?
Your answer should be very brief. 0.14. What is the ratio of the HFC emissions (in thousand metric tons of CO2 equivalent) in 1990 in Malaysia to that in Mexico?
Your answer should be very brief. 0. What is the ratio of the HFC emissions (in thousand metric tons of CO2 equivalent) in 2000 in Malaysia to that in Mexico?
Provide a short and direct response. 0. What is the ratio of the HFC emissions (in thousand metric tons of CO2 equivalent) in 2005 in Malaysia to that in Mexico?
Your answer should be compact. 0. What is the ratio of the HFC emissions (in thousand metric tons of CO2 equivalent) of 2008 in Malaysia to that in Mexico?
Offer a terse response. 0. What is the ratio of the HFC emissions (in thousand metric tons of CO2 equivalent) of 2000 in Malaysia to that in Netherlands?
Ensure brevity in your answer.  0. What is the ratio of the HFC emissions (in thousand metric tons of CO2 equivalent) in 2005 in Malaysia to that in Netherlands?
Provide a short and direct response. 0.01. What is the ratio of the HFC emissions (in thousand metric tons of CO2 equivalent) in 2008 in Malaysia to that in Netherlands?
Offer a terse response. 0.01. What is the ratio of the HFC emissions (in thousand metric tons of CO2 equivalent) in 2000 in Malaysia to that in New Zealand?
Offer a terse response. 0.02. What is the ratio of the HFC emissions (in thousand metric tons of CO2 equivalent) in 2005 in Malaysia to that in New Zealand?
Provide a succinct answer. 0.04. What is the ratio of the HFC emissions (in thousand metric tons of CO2 equivalent) in 2008 in Malaysia to that in New Zealand?
Your response must be concise. 0.04. What is the ratio of the HFC emissions (in thousand metric tons of CO2 equivalent) in 1990 in Mexico to that in Netherlands?
Keep it short and to the point. 0.57. What is the ratio of the HFC emissions (in thousand metric tons of CO2 equivalent) in 2000 in Mexico to that in Netherlands?
Give a very brief answer. 0.54. What is the ratio of the HFC emissions (in thousand metric tons of CO2 equivalent) of 2005 in Mexico to that in Netherlands?
Offer a terse response. 2.26. What is the ratio of the HFC emissions (in thousand metric tons of CO2 equivalent) of 2008 in Mexico to that in Netherlands?
Make the answer very short. 2.21. What is the ratio of the HFC emissions (in thousand metric tons of CO2 equivalent) in 1990 in Mexico to that in New Zealand?
Give a very brief answer. 7976.5. What is the ratio of the HFC emissions (in thousand metric tons of CO2 equivalent) of 2000 in Mexico to that in New Zealand?
Ensure brevity in your answer.  9.64. What is the ratio of the HFC emissions (in thousand metric tons of CO2 equivalent) of 2005 in Mexico to that in New Zealand?
Your answer should be very brief. 9.78. What is the ratio of the HFC emissions (in thousand metric tons of CO2 equivalent) of 2008 in Mexico to that in New Zealand?
Ensure brevity in your answer.  9.06. What is the ratio of the HFC emissions (in thousand metric tons of CO2 equivalent) of 1990 in Netherlands to that in New Zealand?
Ensure brevity in your answer.  1.40e+04. What is the ratio of the HFC emissions (in thousand metric tons of CO2 equivalent) in 2000 in Netherlands to that in New Zealand?
Give a very brief answer. 17.85. What is the ratio of the HFC emissions (in thousand metric tons of CO2 equivalent) of 2005 in Netherlands to that in New Zealand?
Provide a succinct answer. 4.32. What is the ratio of the HFC emissions (in thousand metric tons of CO2 equivalent) in 2008 in Netherlands to that in New Zealand?
Ensure brevity in your answer.  4.11. What is the difference between the highest and the second highest HFC emissions (in thousand metric tons of CO2 equivalent) of 1990?
Ensure brevity in your answer.  1197.6. What is the difference between the highest and the second highest HFC emissions (in thousand metric tons of CO2 equivalent) in 2000?
Your response must be concise. 2853.1. What is the difference between the highest and the second highest HFC emissions (in thousand metric tons of CO2 equivalent) in 2005?
Keep it short and to the point. 3939.4. What is the difference between the highest and the second highest HFC emissions (in thousand metric tons of CO2 equivalent) of 2008?
Your answer should be very brief. 4808.1. What is the difference between the highest and the lowest HFC emissions (in thousand metric tons of CO2 equivalent) of 1990?
Your response must be concise. 2792.8. What is the difference between the highest and the lowest HFC emissions (in thousand metric tons of CO2 equivalent) in 2000?
Your answer should be compact. 6193.5. What is the difference between the highest and the lowest HFC emissions (in thousand metric tons of CO2 equivalent) of 2005?
Offer a terse response. 7032.8. What is the difference between the highest and the lowest HFC emissions (in thousand metric tons of CO2 equivalent) of 2008?
Offer a terse response. 8757.7. 